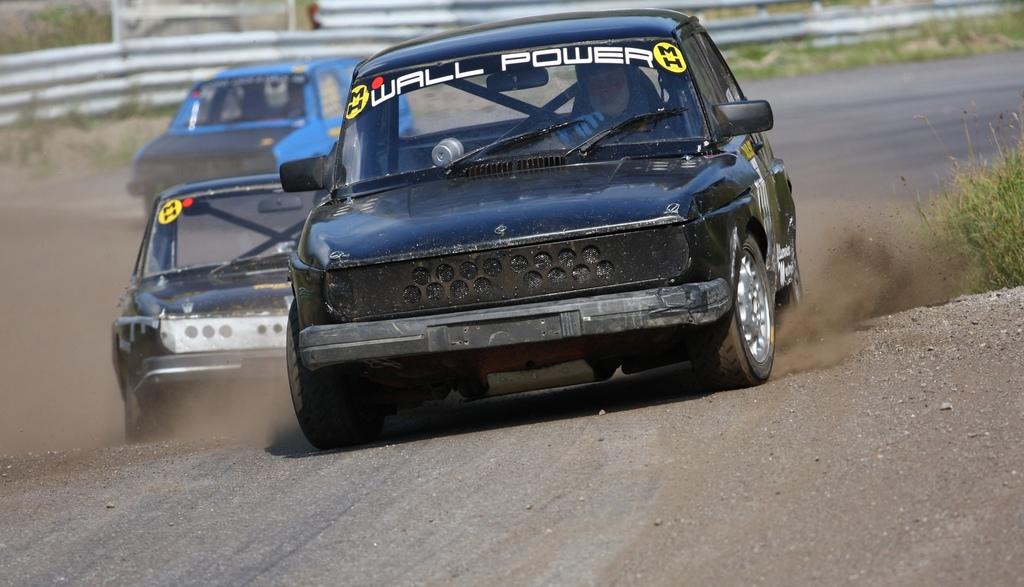What is the main subject of the image? There is a man in a car in the image. How many other cars are visible in the image? There are two other cars behind the first car. What can be seen in the background of the image? There is a fence visible in the image, and plants are behind the vehicles. What type of flag can be seen flying over the harbor in the image? There is no flag or harbor present in the image; it features a man in a car and two other cars behind it, with a fence and plants in the background. 